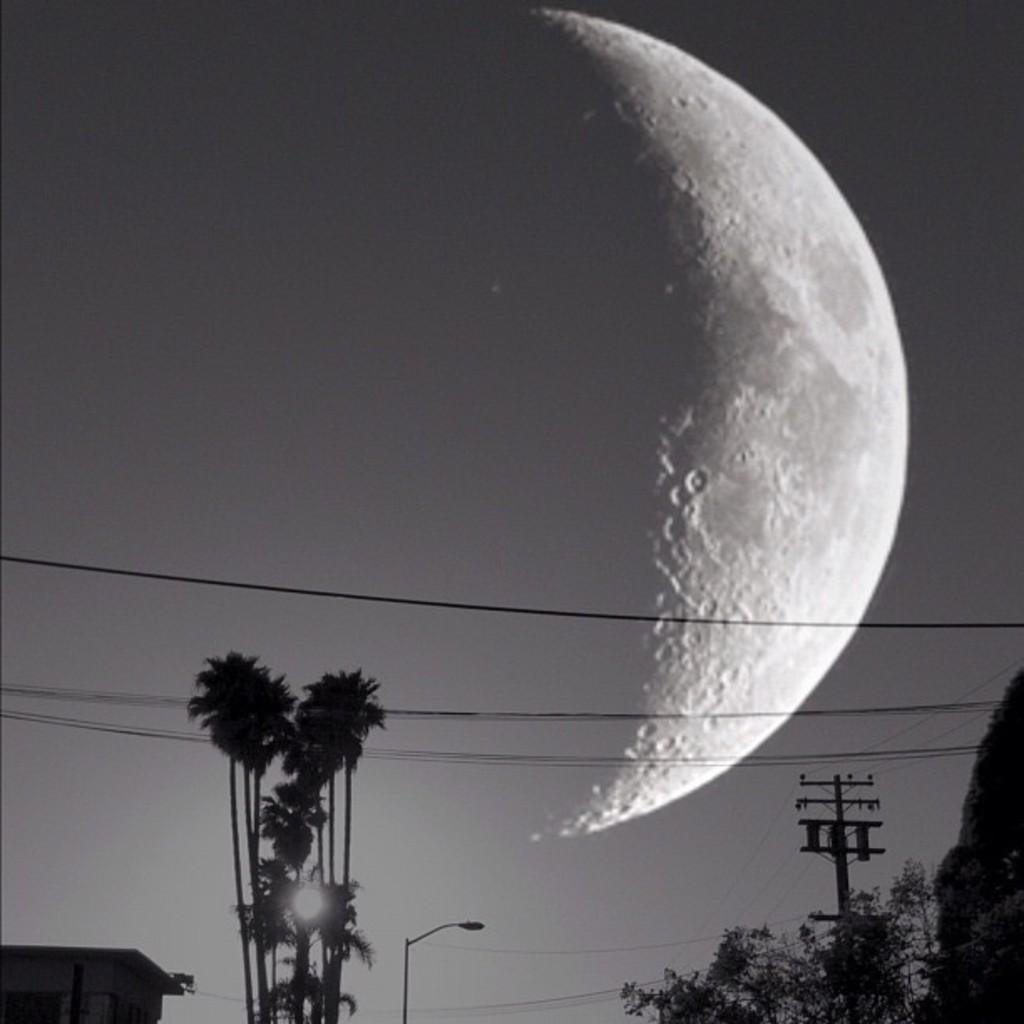What is the color scheme of the image? The image is black and white. What can be seen at the bottom of the image? There are trees and a street light at the bottom of the image. What is the pole in the image used for? The pole in the image is likely used to support wires. What else can be seen at the bottom of the image? There are objects at the bottom of the image, which could be various structures or items. What is visible in the sky in the background of the image? The moon is visible in the sky in the background of the image. What type of meat is being cooked on the pole in the image? There is no meat or cooking activity present in the image. The pole is likely used to support wires. 